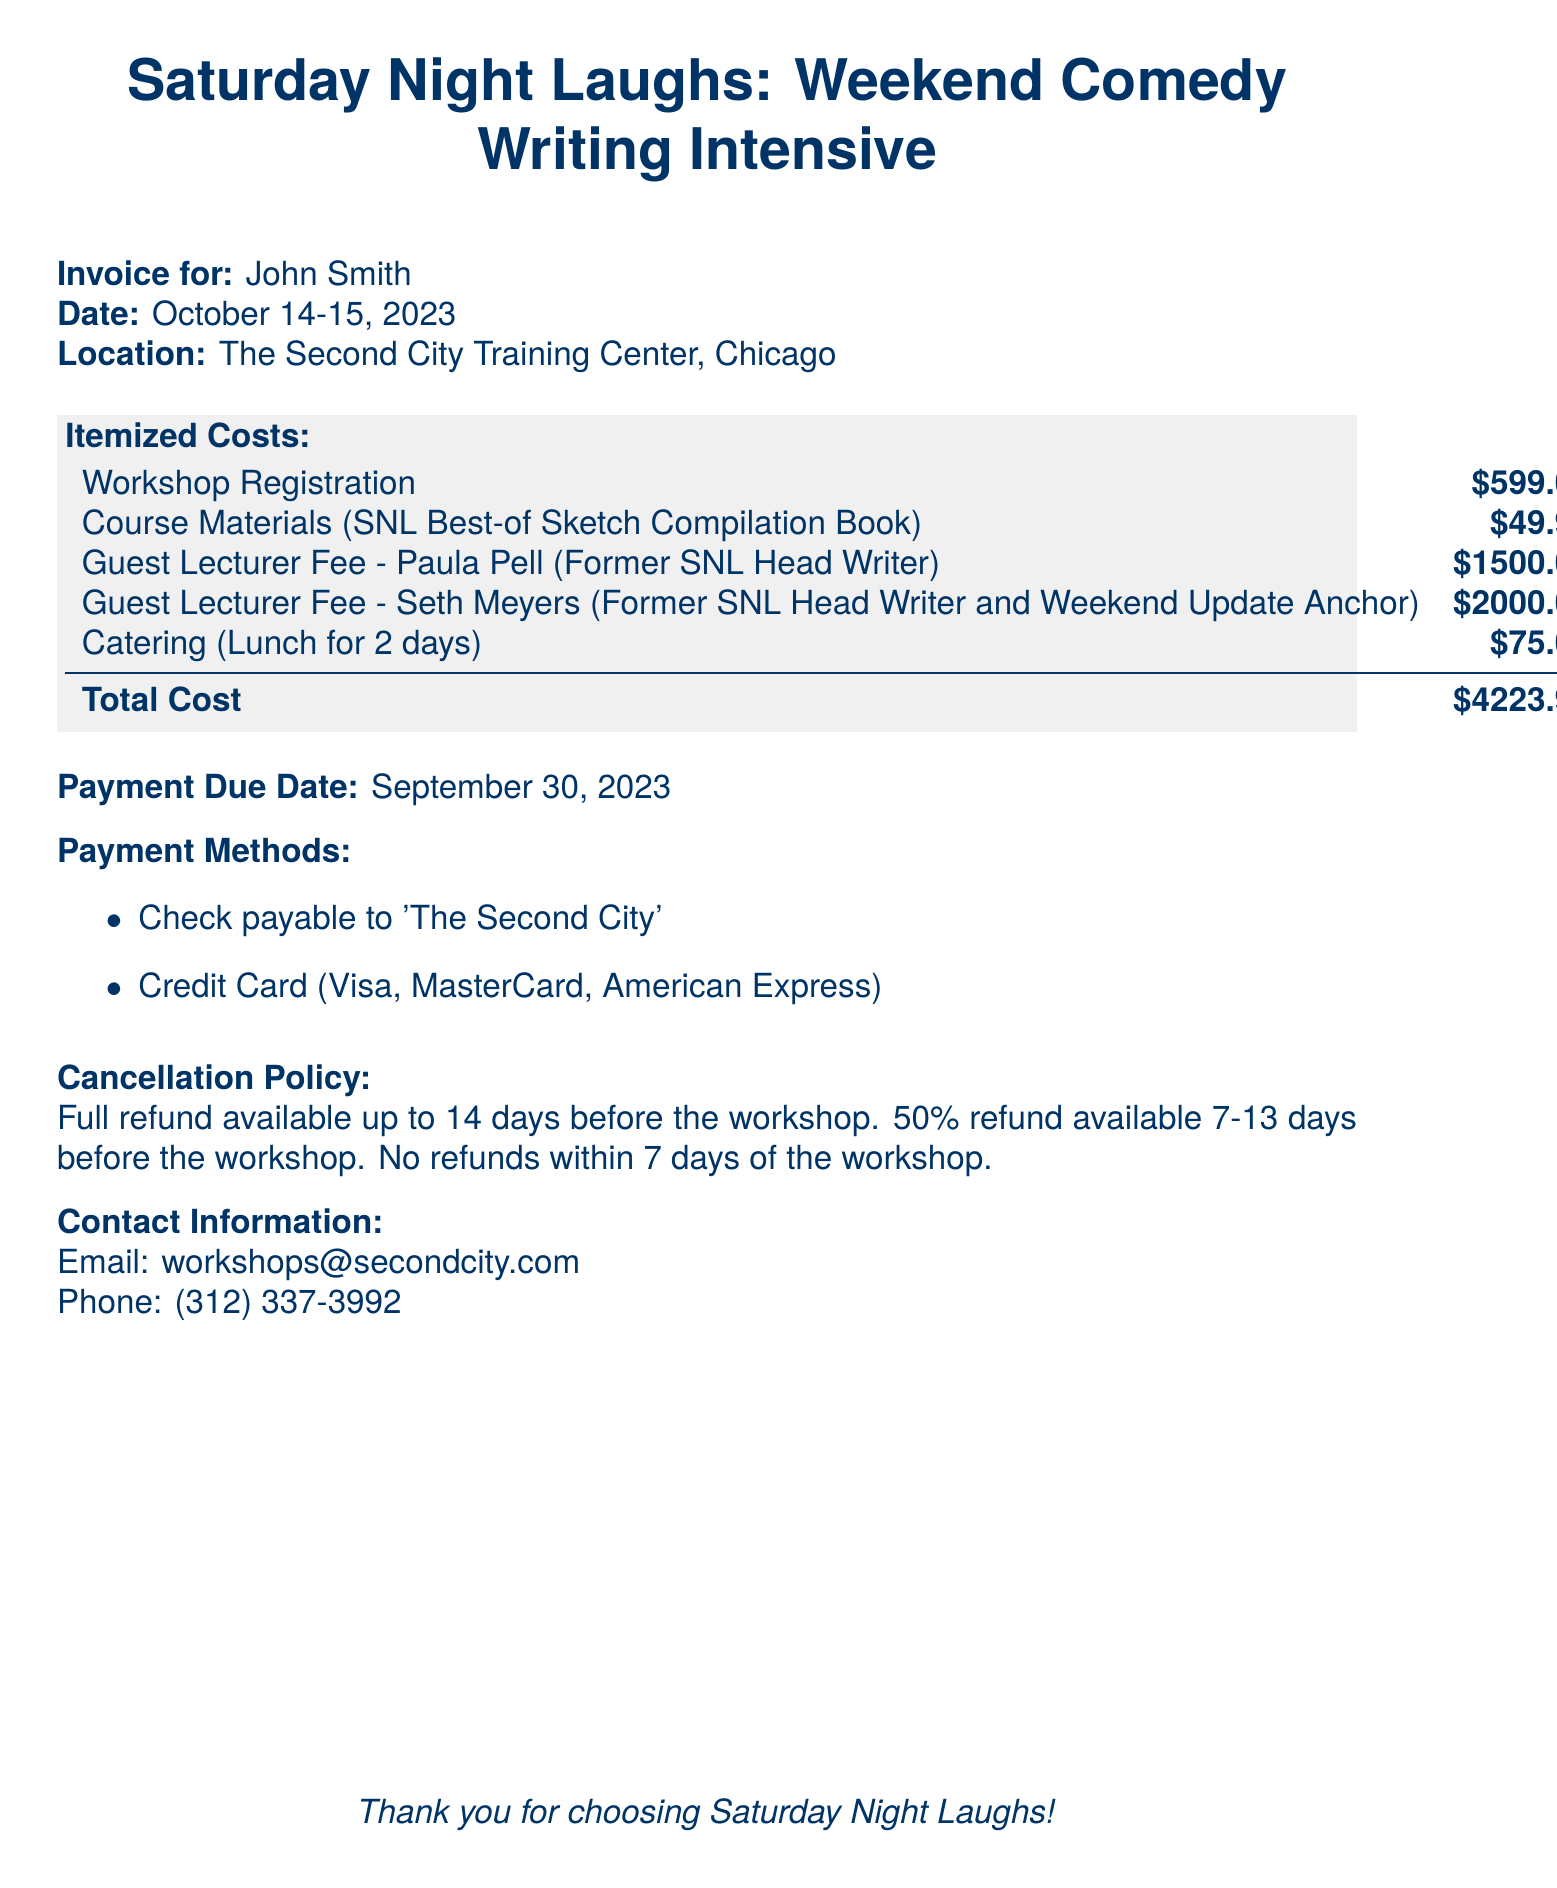What is the total cost? The total cost is provided in the itemized list at the bottom right of the invoice.
Answer: $4223.99 Who is the guest lecturer that is a former head writer of SNL? The document lists Paula Pell as the guest lecturer who was a former head writer of SNL.
Answer: Paula Pell What is the payment due date? The document states the due date for payment.
Answer: September 30, 2023 How much is the workshop registration fee? The workshop registration fee is listed in the itemized costs section of the invoice.
Answer: $599.00 What is the cancellation policy for refunds? The cancellation policy mentions the conditions under which refunds are available, which are based on the number of days before the workshop.
Answer: Full refund available up to 14 days before What methods of payment are accepted? The document outlines the accepted forms of payment for the workshop.
Answer: Check, Credit Card How many guest lecturers are listed in the document? The document mentions two guest lecturers for the workshop.
Answer: 2 What is included in the course materials? The course materials are specified in the itemized costs section of the invoice.
Answer: SNL Best-of Sketch Compilation Book What is the location of the workshop? The workshop location is stated near the top of the invoice.
Answer: The Second City Training Center, Chicago 